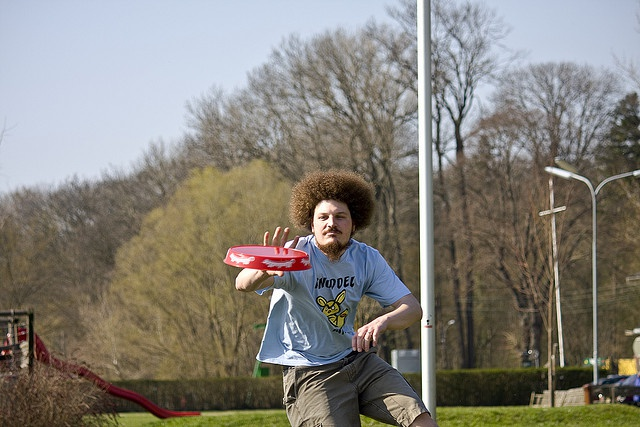Describe the objects in this image and their specific colors. I can see people in darkgray, black, and gray tones, frisbee in darkgray, lightpink, brown, white, and salmon tones, car in darkgray and gray tones, and car in darkgray, black, gray, navy, and darkblue tones in this image. 